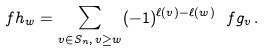Convert formula to latex. <formula><loc_0><loc_0><loc_500><loc_500>\ f h _ { w } = \sum _ { v \in S _ { n } , \, v \geq w } ( - 1 ) ^ { \ell ( v ) - \ell ( w ) } \ f g _ { v } \, .</formula> 